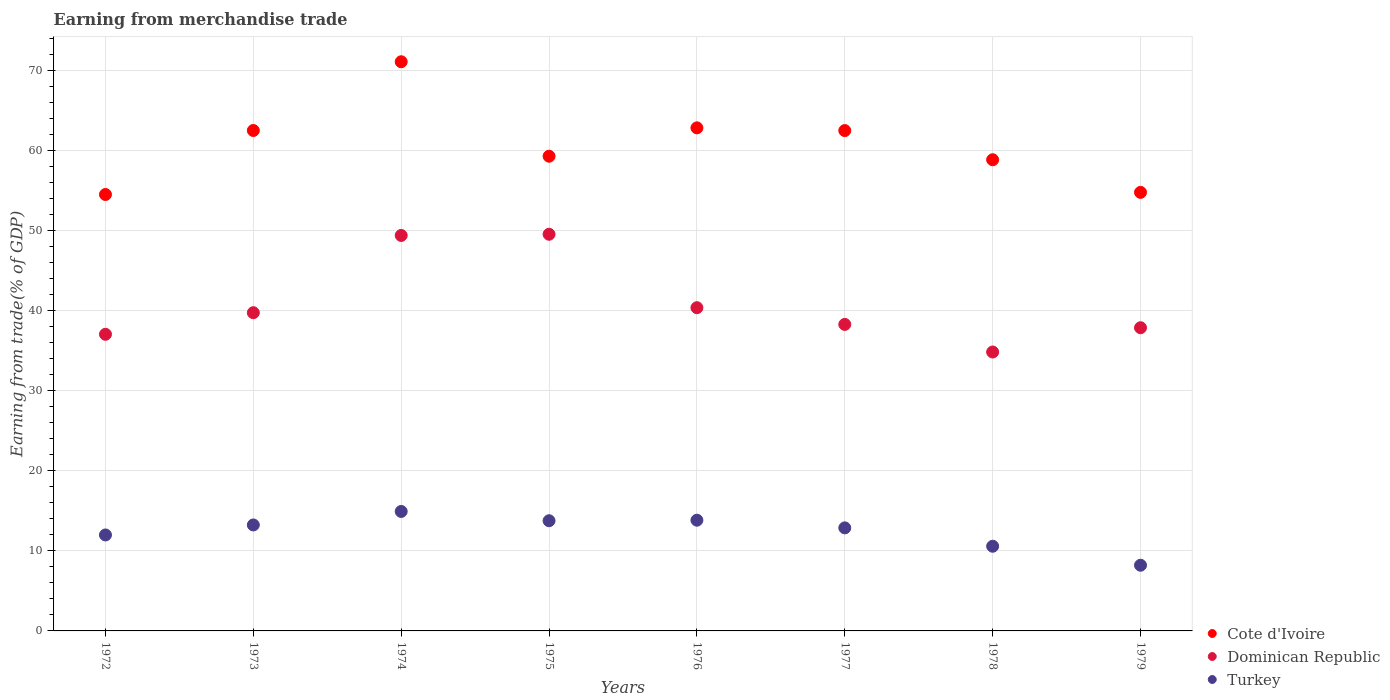Is the number of dotlines equal to the number of legend labels?
Provide a succinct answer. Yes. What is the earnings from trade in Turkey in 1974?
Give a very brief answer. 14.92. Across all years, what is the maximum earnings from trade in Turkey?
Keep it short and to the point. 14.92. Across all years, what is the minimum earnings from trade in Cote d'Ivoire?
Your answer should be very brief. 54.48. In which year was the earnings from trade in Dominican Republic maximum?
Your response must be concise. 1975. In which year was the earnings from trade in Cote d'Ivoire minimum?
Ensure brevity in your answer.  1972. What is the total earnings from trade in Cote d'Ivoire in the graph?
Your response must be concise. 486.13. What is the difference between the earnings from trade in Cote d'Ivoire in 1974 and that in 1978?
Provide a succinct answer. 12.23. What is the difference between the earnings from trade in Turkey in 1972 and the earnings from trade in Cote d'Ivoire in 1976?
Offer a very short reply. -50.83. What is the average earnings from trade in Cote d'Ivoire per year?
Offer a terse response. 60.77. In the year 1977, what is the difference between the earnings from trade in Cote d'Ivoire and earnings from trade in Dominican Republic?
Give a very brief answer. 24.2. What is the ratio of the earnings from trade in Dominican Republic in 1975 to that in 1977?
Offer a very short reply. 1.29. Is the difference between the earnings from trade in Cote d'Ivoire in 1977 and 1979 greater than the difference between the earnings from trade in Dominican Republic in 1977 and 1979?
Offer a terse response. Yes. What is the difference between the highest and the second highest earnings from trade in Turkey?
Offer a terse response. 1.09. What is the difference between the highest and the lowest earnings from trade in Cote d'Ivoire?
Your response must be concise. 16.57. Is the sum of the earnings from trade in Turkey in 1972 and 1975 greater than the maximum earnings from trade in Cote d'Ivoire across all years?
Provide a short and direct response. No. Is the earnings from trade in Dominican Republic strictly greater than the earnings from trade in Cote d'Ivoire over the years?
Ensure brevity in your answer.  No. Is the earnings from trade in Cote d'Ivoire strictly less than the earnings from trade in Turkey over the years?
Give a very brief answer. No. How many dotlines are there?
Your answer should be compact. 3. How many years are there in the graph?
Offer a very short reply. 8. Does the graph contain any zero values?
Your answer should be compact. No. Does the graph contain grids?
Your answer should be compact. Yes. How many legend labels are there?
Your answer should be very brief. 3. How are the legend labels stacked?
Keep it short and to the point. Vertical. What is the title of the graph?
Offer a terse response. Earning from merchandise trade. What is the label or title of the Y-axis?
Offer a very short reply. Earning from trade(% of GDP). What is the Earning from trade(% of GDP) of Cote d'Ivoire in 1972?
Make the answer very short. 54.48. What is the Earning from trade(% of GDP) of Dominican Republic in 1972?
Offer a terse response. 37.03. What is the Earning from trade(% of GDP) in Turkey in 1972?
Offer a terse response. 11.98. What is the Earning from trade(% of GDP) in Cote d'Ivoire in 1973?
Make the answer very short. 62.47. What is the Earning from trade(% of GDP) of Dominican Republic in 1973?
Ensure brevity in your answer.  39.73. What is the Earning from trade(% of GDP) of Turkey in 1973?
Provide a short and direct response. 13.23. What is the Earning from trade(% of GDP) of Cote d'Ivoire in 1974?
Keep it short and to the point. 71.06. What is the Earning from trade(% of GDP) in Dominican Republic in 1974?
Your answer should be compact. 49.37. What is the Earning from trade(% of GDP) in Turkey in 1974?
Give a very brief answer. 14.92. What is the Earning from trade(% of GDP) of Cote d'Ivoire in 1975?
Keep it short and to the point. 59.26. What is the Earning from trade(% of GDP) of Dominican Republic in 1975?
Ensure brevity in your answer.  49.52. What is the Earning from trade(% of GDP) of Turkey in 1975?
Provide a short and direct response. 13.76. What is the Earning from trade(% of GDP) of Cote d'Ivoire in 1976?
Make the answer very short. 62.81. What is the Earning from trade(% of GDP) in Dominican Republic in 1976?
Make the answer very short. 40.35. What is the Earning from trade(% of GDP) of Turkey in 1976?
Your answer should be very brief. 13.82. What is the Earning from trade(% of GDP) in Cote d'Ivoire in 1977?
Offer a terse response. 62.47. What is the Earning from trade(% of GDP) of Dominican Republic in 1977?
Your answer should be compact. 38.27. What is the Earning from trade(% of GDP) of Turkey in 1977?
Make the answer very short. 12.87. What is the Earning from trade(% of GDP) of Cote d'Ivoire in 1978?
Your answer should be compact. 58.82. What is the Earning from trade(% of GDP) in Dominican Republic in 1978?
Offer a terse response. 34.82. What is the Earning from trade(% of GDP) of Turkey in 1978?
Keep it short and to the point. 10.57. What is the Earning from trade(% of GDP) in Cote d'Ivoire in 1979?
Your answer should be compact. 54.75. What is the Earning from trade(% of GDP) in Dominican Republic in 1979?
Ensure brevity in your answer.  37.85. What is the Earning from trade(% of GDP) in Turkey in 1979?
Ensure brevity in your answer.  8.2. Across all years, what is the maximum Earning from trade(% of GDP) of Cote d'Ivoire?
Offer a very short reply. 71.06. Across all years, what is the maximum Earning from trade(% of GDP) of Dominican Republic?
Provide a succinct answer. 49.52. Across all years, what is the maximum Earning from trade(% of GDP) of Turkey?
Keep it short and to the point. 14.92. Across all years, what is the minimum Earning from trade(% of GDP) of Cote d'Ivoire?
Your response must be concise. 54.48. Across all years, what is the minimum Earning from trade(% of GDP) in Dominican Republic?
Give a very brief answer. 34.82. Across all years, what is the minimum Earning from trade(% of GDP) in Turkey?
Your response must be concise. 8.2. What is the total Earning from trade(% of GDP) of Cote d'Ivoire in the graph?
Ensure brevity in your answer.  486.13. What is the total Earning from trade(% of GDP) in Dominican Republic in the graph?
Make the answer very short. 326.95. What is the total Earning from trade(% of GDP) of Turkey in the graph?
Your answer should be compact. 99.34. What is the difference between the Earning from trade(% of GDP) of Cote d'Ivoire in 1972 and that in 1973?
Your answer should be compact. -7.99. What is the difference between the Earning from trade(% of GDP) of Dominican Republic in 1972 and that in 1973?
Give a very brief answer. -2.7. What is the difference between the Earning from trade(% of GDP) in Turkey in 1972 and that in 1973?
Provide a short and direct response. -1.25. What is the difference between the Earning from trade(% of GDP) in Cote d'Ivoire in 1972 and that in 1974?
Your answer should be compact. -16.57. What is the difference between the Earning from trade(% of GDP) in Dominican Republic in 1972 and that in 1974?
Ensure brevity in your answer.  -12.34. What is the difference between the Earning from trade(% of GDP) in Turkey in 1972 and that in 1974?
Provide a short and direct response. -2.94. What is the difference between the Earning from trade(% of GDP) of Cote d'Ivoire in 1972 and that in 1975?
Provide a succinct answer. -4.78. What is the difference between the Earning from trade(% of GDP) in Dominican Republic in 1972 and that in 1975?
Ensure brevity in your answer.  -12.49. What is the difference between the Earning from trade(% of GDP) of Turkey in 1972 and that in 1975?
Give a very brief answer. -1.78. What is the difference between the Earning from trade(% of GDP) in Cote d'Ivoire in 1972 and that in 1976?
Make the answer very short. -8.32. What is the difference between the Earning from trade(% of GDP) of Dominican Republic in 1972 and that in 1976?
Ensure brevity in your answer.  -3.32. What is the difference between the Earning from trade(% of GDP) in Turkey in 1972 and that in 1976?
Your answer should be very brief. -1.84. What is the difference between the Earning from trade(% of GDP) of Cote d'Ivoire in 1972 and that in 1977?
Provide a succinct answer. -7.98. What is the difference between the Earning from trade(% of GDP) of Dominican Republic in 1972 and that in 1977?
Your answer should be compact. -1.23. What is the difference between the Earning from trade(% of GDP) of Turkey in 1972 and that in 1977?
Provide a short and direct response. -0.89. What is the difference between the Earning from trade(% of GDP) in Cote d'Ivoire in 1972 and that in 1978?
Your answer should be very brief. -4.34. What is the difference between the Earning from trade(% of GDP) in Dominican Republic in 1972 and that in 1978?
Ensure brevity in your answer.  2.21. What is the difference between the Earning from trade(% of GDP) of Turkey in 1972 and that in 1978?
Give a very brief answer. 1.41. What is the difference between the Earning from trade(% of GDP) of Cote d'Ivoire in 1972 and that in 1979?
Give a very brief answer. -0.27. What is the difference between the Earning from trade(% of GDP) in Dominican Republic in 1972 and that in 1979?
Provide a short and direct response. -0.82. What is the difference between the Earning from trade(% of GDP) of Turkey in 1972 and that in 1979?
Provide a succinct answer. 3.78. What is the difference between the Earning from trade(% of GDP) of Cote d'Ivoire in 1973 and that in 1974?
Provide a short and direct response. -8.58. What is the difference between the Earning from trade(% of GDP) of Dominican Republic in 1973 and that in 1974?
Give a very brief answer. -9.64. What is the difference between the Earning from trade(% of GDP) of Turkey in 1973 and that in 1974?
Your response must be concise. -1.69. What is the difference between the Earning from trade(% of GDP) in Cote d'Ivoire in 1973 and that in 1975?
Offer a terse response. 3.21. What is the difference between the Earning from trade(% of GDP) of Dominican Republic in 1973 and that in 1975?
Your answer should be compact. -9.79. What is the difference between the Earning from trade(% of GDP) of Turkey in 1973 and that in 1975?
Offer a terse response. -0.53. What is the difference between the Earning from trade(% of GDP) in Cote d'Ivoire in 1973 and that in 1976?
Provide a succinct answer. -0.33. What is the difference between the Earning from trade(% of GDP) in Dominican Republic in 1973 and that in 1976?
Provide a succinct answer. -0.62. What is the difference between the Earning from trade(% of GDP) in Turkey in 1973 and that in 1976?
Give a very brief answer. -0.59. What is the difference between the Earning from trade(% of GDP) of Cote d'Ivoire in 1973 and that in 1977?
Your response must be concise. 0.01. What is the difference between the Earning from trade(% of GDP) in Dominican Republic in 1973 and that in 1977?
Give a very brief answer. 1.46. What is the difference between the Earning from trade(% of GDP) in Turkey in 1973 and that in 1977?
Offer a very short reply. 0.36. What is the difference between the Earning from trade(% of GDP) in Cote d'Ivoire in 1973 and that in 1978?
Your response must be concise. 3.65. What is the difference between the Earning from trade(% of GDP) of Dominican Republic in 1973 and that in 1978?
Provide a short and direct response. 4.91. What is the difference between the Earning from trade(% of GDP) of Turkey in 1973 and that in 1978?
Your answer should be compact. 2.66. What is the difference between the Earning from trade(% of GDP) of Cote d'Ivoire in 1973 and that in 1979?
Your response must be concise. 7.72. What is the difference between the Earning from trade(% of GDP) of Dominican Republic in 1973 and that in 1979?
Offer a terse response. 1.88. What is the difference between the Earning from trade(% of GDP) of Turkey in 1973 and that in 1979?
Your response must be concise. 5.03. What is the difference between the Earning from trade(% of GDP) of Cote d'Ivoire in 1974 and that in 1975?
Provide a succinct answer. 11.79. What is the difference between the Earning from trade(% of GDP) of Dominican Republic in 1974 and that in 1975?
Offer a terse response. -0.15. What is the difference between the Earning from trade(% of GDP) in Turkey in 1974 and that in 1975?
Ensure brevity in your answer.  1.16. What is the difference between the Earning from trade(% of GDP) in Cote d'Ivoire in 1974 and that in 1976?
Offer a terse response. 8.25. What is the difference between the Earning from trade(% of GDP) of Dominican Republic in 1974 and that in 1976?
Your answer should be very brief. 9.02. What is the difference between the Earning from trade(% of GDP) of Turkey in 1974 and that in 1976?
Offer a terse response. 1.09. What is the difference between the Earning from trade(% of GDP) of Cote d'Ivoire in 1974 and that in 1977?
Offer a terse response. 8.59. What is the difference between the Earning from trade(% of GDP) in Dominican Republic in 1974 and that in 1977?
Ensure brevity in your answer.  11.11. What is the difference between the Earning from trade(% of GDP) of Turkey in 1974 and that in 1977?
Make the answer very short. 2.05. What is the difference between the Earning from trade(% of GDP) in Cote d'Ivoire in 1974 and that in 1978?
Offer a terse response. 12.23. What is the difference between the Earning from trade(% of GDP) of Dominican Republic in 1974 and that in 1978?
Provide a short and direct response. 14.55. What is the difference between the Earning from trade(% of GDP) in Turkey in 1974 and that in 1978?
Offer a terse response. 4.34. What is the difference between the Earning from trade(% of GDP) in Cote d'Ivoire in 1974 and that in 1979?
Give a very brief answer. 16.31. What is the difference between the Earning from trade(% of GDP) in Dominican Republic in 1974 and that in 1979?
Make the answer very short. 11.52. What is the difference between the Earning from trade(% of GDP) of Turkey in 1974 and that in 1979?
Ensure brevity in your answer.  6.71. What is the difference between the Earning from trade(% of GDP) of Cote d'Ivoire in 1975 and that in 1976?
Keep it short and to the point. -3.54. What is the difference between the Earning from trade(% of GDP) of Dominican Republic in 1975 and that in 1976?
Your response must be concise. 9.17. What is the difference between the Earning from trade(% of GDP) of Turkey in 1975 and that in 1976?
Provide a succinct answer. -0.07. What is the difference between the Earning from trade(% of GDP) in Cote d'Ivoire in 1975 and that in 1977?
Your response must be concise. -3.2. What is the difference between the Earning from trade(% of GDP) of Dominican Republic in 1975 and that in 1977?
Your response must be concise. 11.25. What is the difference between the Earning from trade(% of GDP) of Turkey in 1975 and that in 1977?
Your response must be concise. 0.89. What is the difference between the Earning from trade(% of GDP) in Cote d'Ivoire in 1975 and that in 1978?
Provide a short and direct response. 0.44. What is the difference between the Earning from trade(% of GDP) of Dominican Republic in 1975 and that in 1978?
Your answer should be compact. 14.7. What is the difference between the Earning from trade(% of GDP) in Turkey in 1975 and that in 1978?
Ensure brevity in your answer.  3.18. What is the difference between the Earning from trade(% of GDP) in Cote d'Ivoire in 1975 and that in 1979?
Your answer should be very brief. 4.51. What is the difference between the Earning from trade(% of GDP) of Dominican Republic in 1975 and that in 1979?
Make the answer very short. 11.67. What is the difference between the Earning from trade(% of GDP) in Turkey in 1975 and that in 1979?
Keep it short and to the point. 5.56. What is the difference between the Earning from trade(% of GDP) of Cote d'Ivoire in 1976 and that in 1977?
Offer a terse response. 0.34. What is the difference between the Earning from trade(% of GDP) in Dominican Republic in 1976 and that in 1977?
Offer a very short reply. 2.09. What is the difference between the Earning from trade(% of GDP) of Turkey in 1976 and that in 1977?
Ensure brevity in your answer.  0.96. What is the difference between the Earning from trade(% of GDP) of Cote d'Ivoire in 1976 and that in 1978?
Your response must be concise. 3.98. What is the difference between the Earning from trade(% of GDP) in Dominican Republic in 1976 and that in 1978?
Your response must be concise. 5.53. What is the difference between the Earning from trade(% of GDP) in Turkey in 1976 and that in 1978?
Your response must be concise. 3.25. What is the difference between the Earning from trade(% of GDP) of Cote d'Ivoire in 1976 and that in 1979?
Keep it short and to the point. 8.05. What is the difference between the Earning from trade(% of GDP) of Dominican Republic in 1976 and that in 1979?
Provide a succinct answer. 2.5. What is the difference between the Earning from trade(% of GDP) of Turkey in 1976 and that in 1979?
Make the answer very short. 5.62. What is the difference between the Earning from trade(% of GDP) of Cote d'Ivoire in 1977 and that in 1978?
Keep it short and to the point. 3.64. What is the difference between the Earning from trade(% of GDP) of Dominican Republic in 1977 and that in 1978?
Provide a succinct answer. 3.45. What is the difference between the Earning from trade(% of GDP) in Turkey in 1977 and that in 1978?
Your answer should be compact. 2.29. What is the difference between the Earning from trade(% of GDP) in Cote d'Ivoire in 1977 and that in 1979?
Keep it short and to the point. 7.71. What is the difference between the Earning from trade(% of GDP) in Dominican Republic in 1977 and that in 1979?
Ensure brevity in your answer.  0.42. What is the difference between the Earning from trade(% of GDP) in Turkey in 1977 and that in 1979?
Make the answer very short. 4.67. What is the difference between the Earning from trade(% of GDP) in Cote d'Ivoire in 1978 and that in 1979?
Give a very brief answer. 4.07. What is the difference between the Earning from trade(% of GDP) of Dominican Republic in 1978 and that in 1979?
Provide a succinct answer. -3.03. What is the difference between the Earning from trade(% of GDP) of Turkey in 1978 and that in 1979?
Provide a succinct answer. 2.37. What is the difference between the Earning from trade(% of GDP) of Cote d'Ivoire in 1972 and the Earning from trade(% of GDP) of Dominican Republic in 1973?
Make the answer very short. 14.76. What is the difference between the Earning from trade(% of GDP) of Cote d'Ivoire in 1972 and the Earning from trade(% of GDP) of Turkey in 1973?
Offer a very short reply. 41.25. What is the difference between the Earning from trade(% of GDP) in Dominican Republic in 1972 and the Earning from trade(% of GDP) in Turkey in 1973?
Provide a short and direct response. 23.8. What is the difference between the Earning from trade(% of GDP) in Cote d'Ivoire in 1972 and the Earning from trade(% of GDP) in Dominican Republic in 1974?
Provide a succinct answer. 5.11. What is the difference between the Earning from trade(% of GDP) in Cote d'Ivoire in 1972 and the Earning from trade(% of GDP) in Turkey in 1974?
Offer a very short reply. 39.57. What is the difference between the Earning from trade(% of GDP) in Dominican Republic in 1972 and the Earning from trade(% of GDP) in Turkey in 1974?
Your answer should be compact. 22.12. What is the difference between the Earning from trade(% of GDP) of Cote d'Ivoire in 1972 and the Earning from trade(% of GDP) of Dominican Republic in 1975?
Offer a very short reply. 4.96. What is the difference between the Earning from trade(% of GDP) of Cote d'Ivoire in 1972 and the Earning from trade(% of GDP) of Turkey in 1975?
Your answer should be very brief. 40.73. What is the difference between the Earning from trade(% of GDP) of Dominican Republic in 1972 and the Earning from trade(% of GDP) of Turkey in 1975?
Offer a very short reply. 23.28. What is the difference between the Earning from trade(% of GDP) of Cote d'Ivoire in 1972 and the Earning from trade(% of GDP) of Dominican Republic in 1976?
Offer a terse response. 14.13. What is the difference between the Earning from trade(% of GDP) in Cote d'Ivoire in 1972 and the Earning from trade(% of GDP) in Turkey in 1976?
Your answer should be very brief. 40.66. What is the difference between the Earning from trade(% of GDP) in Dominican Republic in 1972 and the Earning from trade(% of GDP) in Turkey in 1976?
Your answer should be very brief. 23.21. What is the difference between the Earning from trade(% of GDP) of Cote d'Ivoire in 1972 and the Earning from trade(% of GDP) of Dominican Republic in 1977?
Your answer should be compact. 16.22. What is the difference between the Earning from trade(% of GDP) in Cote d'Ivoire in 1972 and the Earning from trade(% of GDP) in Turkey in 1977?
Keep it short and to the point. 41.62. What is the difference between the Earning from trade(% of GDP) of Dominican Republic in 1972 and the Earning from trade(% of GDP) of Turkey in 1977?
Ensure brevity in your answer.  24.17. What is the difference between the Earning from trade(% of GDP) of Cote d'Ivoire in 1972 and the Earning from trade(% of GDP) of Dominican Republic in 1978?
Your answer should be very brief. 19.66. What is the difference between the Earning from trade(% of GDP) of Cote d'Ivoire in 1972 and the Earning from trade(% of GDP) of Turkey in 1978?
Offer a very short reply. 43.91. What is the difference between the Earning from trade(% of GDP) in Dominican Republic in 1972 and the Earning from trade(% of GDP) in Turkey in 1978?
Give a very brief answer. 26.46. What is the difference between the Earning from trade(% of GDP) of Cote d'Ivoire in 1972 and the Earning from trade(% of GDP) of Dominican Republic in 1979?
Make the answer very short. 16.63. What is the difference between the Earning from trade(% of GDP) of Cote d'Ivoire in 1972 and the Earning from trade(% of GDP) of Turkey in 1979?
Your answer should be very brief. 46.28. What is the difference between the Earning from trade(% of GDP) in Dominican Republic in 1972 and the Earning from trade(% of GDP) in Turkey in 1979?
Make the answer very short. 28.83. What is the difference between the Earning from trade(% of GDP) of Cote d'Ivoire in 1973 and the Earning from trade(% of GDP) of Dominican Republic in 1974?
Your answer should be very brief. 13.1. What is the difference between the Earning from trade(% of GDP) of Cote d'Ivoire in 1973 and the Earning from trade(% of GDP) of Turkey in 1974?
Keep it short and to the point. 47.56. What is the difference between the Earning from trade(% of GDP) of Dominican Republic in 1973 and the Earning from trade(% of GDP) of Turkey in 1974?
Offer a terse response. 24.81. What is the difference between the Earning from trade(% of GDP) in Cote d'Ivoire in 1973 and the Earning from trade(% of GDP) in Dominican Republic in 1975?
Keep it short and to the point. 12.95. What is the difference between the Earning from trade(% of GDP) of Cote d'Ivoire in 1973 and the Earning from trade(% of GDP) of Turkey in 1975?
Your answer should be very brief. 48.72. What is the difference between the Earning from trade(% of GDP) of Dominican Republic in 1973 and the Earning from trade(% of GDP) of Turkey in 1975?
Your answer should be very brief. 25.97. What is the difference between the Earning from trade(% of GDP) in Cote d'Ivoire in 1973 and the Earning from trade(% of GDP) in Dominican Republic in 1976?
Offer a very short reply. 22.12. What is the difference between the Earning from trade(% of GDP) in Cote d'Ivoire in 1973 and the Earning from trade(% of GDP) in Turkey in 1976?
Offer a terse response. 48.65. What is the difference between the Earning from trade(% of GDP) in Dominican Republic in 1973 and the Earning from trade(% of GDP) in Turkey in 1976?
Keep it short and to the point. 25.9. What is the difference between the Earning from trade(% of GDP) of Cote d'Ivoire in 1973 and the Earning from trade(% of GDP) of Dominican Republic in 1977?
Provide a short and direct response. 24.21. What is the difference between the Earning from trade(% of GDP) in Cote d'Ivoire in 1973 and the Earning from trade(% of GDP) in Turkey in 1977?
Keep it short and to the point. 49.61. What is the difference between the Earning from trade(% of GDP) in Dominican Republic in 1973 and the Earning from trade(% of GDP) in Turkey in 1977?
Make the answer very short. 26.86. What is the difference between the Earning from trade(% of GDP) in Cote d'Ivoire in 1973 and the Earning from trade(% of GDP) in Dominican Republic in 1978?
Your answer should be very brief. 27.65. What is the difference between the Earning from trade(% of GDP) of Cote d'Ivoire in 1973 and the Earning from trade(% of GDP) of Turkey in 1978?
Your response must be concise. 51.9. What is the difference between the Earning from trade(% of GDP) of Dominican Republic in 1973 and the Earning from trade(% of GDP) of Turkey in 1978?
Offer a very short reply. 29.16. What is the difference between the Earning from trade(% of GDP) of Cote d'Ivoire in 1973 and the Earning from trade(% of GDP) of Dominican Republic in 1979?
Offer a terse response. 24.62. What is the difference between the Earning from trade(% of GDP) in Cote d'Ivoire in 1973 and the Earning from trade(% of GDP) in Turkey in 1979?
Offer a terse response. 54.27. What is the difference between the Earning from trade(% of GDP) in Dominican Republic in 1973 and the Earning from trade(% of GDP) in Turkey in 1979?
Give a very brief answer. 31.53. What is the difference between the Earning from trade(% of GDP) of Cote d'Ivoire in 1974 and the Earning from trade(% of GDP) of Dominican Republic in 1975?
Your response must be concise. 21.54. What is the difference between the Earning from trade(% of GDP) of Cote d'Ivoire in 1974 and the Earning from trade(% of GDP) of Turkey in 1975?
Keep it short and to the point. 57.3. What is the difference between the Earning from trade(% of GDP) of Dominican Republic in 1974 and the Earning from trade(% of GDP) of Turkey in 1975?
Give a very brief answer. 35.62. What is the difference between the Earning from trade(% of GDP) in Cote d'Ivoire in 1974 and the Earning from trade(% of GDP) in Dominican Republic in 1976?
Provide a short and direct response. 30.7. What is the difference between the Earning from trade(% of GDP) of Cote d'Ivoire in 1974 and the Earning from trade(% of GDP) of Turkey in 1976?
Keep it short and to the point. 57.23. What is the difference between the Earning from trade(% of GDP) of Dominican Republic in 1974 and the Earning from trade(% of GDP) of Turkey in 1976?
Ensure brevity in your answer.  35.55. What is the difference between the Earning from trade(% of GDP) of Cote d'Ivoire in 1974 and the Earning from trade(% of GDP) of Dominican Republic in 1977?
Your response must be concise. 32.79. What is the difference between the Earning from trade(% of GDP) of Cote d'Ivoire in 1974 and the Earning from trade(% of GDP) of Turkey in 1977?
Offer a very short reply. 58.19. What is the difference between the Earning from trade(% of GDP) in Dominican Republic in 1974 and the Earning from trade(% of GDP) in Turkey in 1977?
Your answer should be very brief. 36.51. What is the difference between the Earning from trade(% of GDP) in Cote d'Ivoire in 1974 and the Earning from trade(% of GDP) in Dominican Republic in 1978?
Provide a succinct answer. 36.24. What is the difference between the Earning from trade(% of GDP) in Cote d'Ivoire in 1974 and the Earning from trade(% of GDP) in Turkey in 1978?
Offer a terse response. 60.49. What is the difference between the Earning from trade(% of GDP) in Dominican Republic in 1974 and the Earning from trade(% of GDP) in Turkey in 1978?
Make the answer very short. 38.8. What is the difference between the Earning from trade(% of GDP) of Cote d'Ivoire in 1974 and the Earning from trade(% of GDP) of Dominican Republic in 1979?
Give a very brief answer. 33.21. What is the difference between the Earning from trade(% of GDP) in Cote d'Ivoire in 1974 and the Earning from trade(% of GDP) in Turkey in 1979?
Keep it short and to the point. 62.86. What is the difference between the Earning from trade(% of GDP) of Dominican Republic in 1974 and the Earning from trade(% of GDP) of Turkey in 1979?
Provide a succinct answer. 41.17. What is the difference between the Earning from trade(% of GDP) of Cote d'Ivoire in 1975 and the Earning from trade(% of GDP) of Dominican Republic in 1976?
Provide a short and direct response. 18.91. What is the difference between the Earning from trade(% of GDP) in Cote d'Ivoire in 1975 and the Earning from trade(% of GDP) in Turkey in 1976?
Offer a very short reply. 45.44. What is the difference between the Earning from trade(% of GDP) in Dominican Republic in 1975 and the Earning from trade(% of GDP) in Turkey in 1976?
Keep it short and to the point. 35.7. What is the difference between the Earning from trade(% of GDP) in Cote d'Ivoire in 1975 and the Earning from trade(% of GDP) in Dominican Republic in 1977?
Offer a very short reply. 21. What is the difference between the Earning from trade(% of GDP) in Cote d'Ivoire in 1975 and the Earning from trade(% of GDP) in Turkey in 1977?
Keep it short and to the point. 46.4. What is the difference between the Earning from trade(% of GDP) in Dominican Republic in 1975 and the Earning from trade(% of GDP) in Turkey in 1977?
Offer a very short reply. 36.66. What is the difference between the Earning from trade(% of GDP) of Cote d'Ivoire in 1975 and the Earning from trade(% of GDP) of Dominican Republic in 1978?
Keep it short and to the point. 24.44. What is the difference between the Earning from trade(% of GDP) of Cote d'Ivoire in 1975 and the Earning from trade(% of GDP) of Turkey in 1978?
Offer a very short reply. 48.69. What is the difference between the Earning from trade(% of GDP) in Dominican Republic in 1975 and the Earning from trade(% of GDP) in Turkey in 1978?
Make the answer very short. 38.95. What is the difference between the Earning from trade(% of GDP) in Cote d'Ivoire in 1975 and the Earning from trade(% of GDP) in Dominican Republic in 1979?
Provide a succinct answer. 21.41. What is the difference between the Earning from trade(% of GDP) of Cote d'Ivoire in 1975 and the Earning from trade(% of GDP) of Turkey in 1979?
Your answer should be compact. 51.06. What is the difference between the Earning from trade(% of GDP) in Dominican Republic in 1975 and the Earning from trade(% of GDP) in Turkey in 1979?
Make the answer very short. 41.32. What is the difference between the Earning from trade(% of GDP) in Cote d'Ivoire in 1976 and the Earning from trade(% of GDP) in Dominican Republic in 1977?
Your response must be concise. 24.54. What is the difference between the Earning from trade(% of GDP) in Cote d'Ivoire in 1976 and the Earning from trade(% of GDP) in Turkey in 1977?
Your answer should be compact. 49.94. What is the difference between the Earning from trade(% of GDP) in Dominican Republic in 1976 and the Earning from trade(% of GDP) in Turkey in 1977?
Offer a terse response. 27.49. What is the difference between the Earning from trade(% of GDP) in Cote d'Ivoire in 1976 and the Earning from trade(% of GDP) in Dominican Republic in 1978?
Provide a succinct answer. 27.98. What is the difference between the Earning from trade(% of GDP) of Cote d'Ivoire in 1976 and the Earning from trade(% of GDP) of Turkey in 1978?
Offer a terse response. 52.23. What is the difference between the Earning from trade(% of GDP) of Dominican Republic in 1976 and the Earning from trade(% of GDP) of Turkey in 1978?
Ensure brevity in your answer.  29.78. What is the difference between the Earning from trade(% of GDP) of Cote d'Ivoire in 1976 and the Earning from trade(% of GDP) of Dominican Republic in 1979?
Give a very brief answer. 24.95. What is the difference between the Earning from trade(% of GDP) in Cote d'Ivoire in 1976 and the Earning from trade(% of GDP) in Turkey in 1979?
Make the answer very short. 54.6. What is the difference between the Earning from trade(% of GDP) of Dominican Republic in 1976 and the Earning from trade(% of GDP) of Turkey in 1979?
Keep it short and to the point. 32.15. What is the difference between the Earning from trade(% of GDP) in Cote d'Ivoire in 1977 and the Earning from trade(% of GDP) in Dominican Republic in 1978?
Give a very brief answer. 27.64. What is the difference between the Earning from trade(% of GDP) in Cote d'Ivoire in 1977 and the Earning from trade(% of GDP) in Turkey in 1978?
Provide a succinct answer. 51.89. What is the difference between the Earning from trade(% of GDP) of Dominican Republic in 1977 and the Earning from trade(% of GDP) of Turkey in 1978?
Provide a short and direct response. 27.7. What is the difference between the Earning from trade(% of GDP) in Cote d'Ivoire in 1977 and the Earning from trade(% of GDP) in Dominican Republic in 1979?
Provide a succinct answer. 24.61. What is the difference between the Earning from trade(% of GDP) in Cote d'Ivoire in 1977 and the Earning from trade(% of GDP) in Turkey in 1979?
Provide a short and direct response. 54.26. What is the difference between the Earning from trade(% of GDP) in Dominican Republic in 1977 and the Earning from trade(% of GDP) in Turkey in 1979?
Keep it short and to the point. 30.07. What is the difference between the Earning from trade(% of GDP) of Cote d'Ivoire in 1978 and the Earning from trade(% of GDP) of Dominican Republic in 1979?
Your answer should be very brief. 20.97. What is the difference between the Earning from trade(% of GDP) of Cote d'Ivoire in 1978 and the Earning from trade(% of GDP) of Turkey in 1979?
Give a very brief answer. 50.62. What is the difference between the Earning from trade(% of GDP) of Dominican Republic in 1978 and the Earning from trade(% of GDP) of Turkey in 1979?
Offer a terse response. 26.62. What is the average Earning from trade(% of GDP) of Cote d'Ivoire per year?
Provide a succinct answer. 60.77. What is the average Earning from trade(% of GDP) in Dominican Republic per year?
Give a very brief answer. 40.87. What is the average Earning from trade(% of GDP) in Turkey per year?
Keep it short and to the point. 12.42. In the year 1972, what is the difference between the Earning from trade(% of GDP) of Cote d'Ivoire and Earning from trade(% of GDP) of Dominican Republic?
Provide a short and direct response. 17.45. In the year 1972, what is the difference between the Earning from trade(% of GDP) of Cote d'Ivoire and Earning from trade(% of GDP) of Turkey?
Make the answer very short. 42.5. In the year 1972, what is the difference between the Earning from trade(% of GDP) of Dominican Republic and Earning from trade(% of GDP) of Turkey?
Provide a short and direct response. 25.05. In the year 1973, what is the difference between the Earning from trade(% of GDP) of Cote d'Ivoire and Earning from trade(% of GDP) of Dominican Republic?
Offer a terse response. 22.75. In the year 1973, what is the difference between the Earning from trade(% of GDP) of Cote d'Ivoire and Earning from trade(% of GDP) of Turkey?
Your answer should be very brief. 49.25. In the year 1973, what is the difference between the Earning from trade(% of GDP) of Dominican Republic and Earning from trade(% of GDP) of Turkey?
Provide a short and direct response. 26.5. In the year 1974, what is the difference between the Earning from trade(% of GDP) of Cote d'Ivoire and Earning from trade(% of GDP) of Dominican Republic?
Keep it short and to the point. 21.69. In the year 1974, what is the difference between the Earning from trade(% of GDP) of Cote d'Ivoire and Earning from trade(% of GDP) of Turkey?
Your response must be concise. 56.14. In the year 1974, what is the difference between the Earning from trade(% of GDP) of Dominican Republic and Earning from trade(% of GDP) of Turkey?
Ensure brevity in your answer.  34.46. In the year 1975, what is the difference between the Earning from trade(% of GDP) in Cote d'Ivoire and Earning from trade(% of GDP) in Dominican Republic?
Your response must be concise. 9.74. In the year 1975, what is the difference between the Earning from trade(% of GDP) in Cote d'Ivoire and Earning from trade(% of GDP) in Turkey?
Keep it short and to the point. 45.51. In the year 1975, what is the difference between the Earning from trade(% of GDP) in Dominican Republic and Earning from trade(% of GDP) in Turkey?
Keep it short and to the point. 35.77. In the year 1976, what is the difference between the Earning from trade(% of GDP) in Cote d'Ivoire and Earning from trade(% of GDP) in Dominican Republic?
Offer a very short reply. 22.45. In the year 1976, what is the difference between the Earning from trade(% of GDP) in Cote d'Ivoire and Earning from trade(% of GDP) in Turkey?
Offer a terse response. 48.98. In the year 1976, what is the difference between the Earning from trade(% of GDP) of Dominican Republic and Earning from trade(% of GDP) of Turkey?
Your response must be concise. 26.53. In the year 1977, what is the difference between the Earning from trade(% of GDP) of Cote d'Ivoire and Earning from trade(% of GDP) of Dominican Republic?
Provide a short and direct response. 24.2. In the year 1977, what is the difference between the Earning from trade(% of GDP) of Cote d'Ivoire and Earning from trade(% of GDP) of Turkey?
Your response must be concise. 49.6. In the year 1977, what is the difference between the Earning from trade(% of GDP) of Dominican Republic and Earning from trade(% of GDP) of Turkey?
Your response must be concise. 25.4. In the year 1978, what is the difference between the Earning from trade(% of GDP) in Cote d'Ivoire and Earning from trade(% of GDP) in Dominican Republic?
Keep it short and to the point. 24. In the year 1978, what is the difference between the Earning from trade(% of GDP) of Cote d'Ivoire and Earning from trade(% of GDP) of Turkey?
Your response must be concise. 48.25. In the year 1978, what is the difference between the Earning from trade(% of GDP) of Dominican Republic and Earning from trade(% of GDP) of Turkey?
Provide a short and direct response. 24.25. In the year 1979, what is the difference between the Earning from trade(% of GDP) of Cote d'Ivoire and Earning from trade(% of GDP) of Dominican Republic?
Provide a short and direct response. 16.9. In the year 1979, what is the difference between the Earning from trade(% of GDP) in Cote d'Ivoire and Earning from trade(% of GDP) in Turkey?
Your response must be concise. 46.55. In the year 1979, what is the difference between the Earning from trade(% of GDP) in Dominican Republic and Earning from trade(% of GDP) in Turkey?
Offer a very short reply. 29.65. What is the ratio of the Earning from trade(% of GDP) of Cote d'Ivoire in 1972 to that in 1973?
Provide a short and direct response. 0.87. What is the ratio of the Earning from trade(% of GDP) of Dominican Republic in 1972 to that in 1973?
Offer a very short reply. 0.93. What is the ratio of the Earning from trade(% of GDP) in Turkey in 1972 to that in 1973?
Your response must be concise. 0.91. What is the ratio of the Earning from trade(% of GDP) of Cote d'Ivoire in 1972 to that in 1974?
Offer a very short reply. 0.77. What is the ratio of the Earning from trade(% of GDP) of Dominican Republic in 1972 to that in 1974?
Provide a succinct answer. 0.75. What is the ratio of the Earning from trade(% of GDP) in Turkey in 1972 to that in 1974?
Ensure brevity in your answer.  0.8. What is the ratio of the Earning from trade(% of GDP) of Cote d'Ivoire in 1972 to that in 1975?
Your answer should be compact. 0.92. What is the ratio of the Earning from trade(% of GDP) of Dominican Republic in 1972 to that in 1975?
Your answer should be very brief. 0.75. What is the ratio of the Earning from trade(% of GDP) in Turkey in 1972 to that in 1975?
Your response must be concise. 0.87. What is the ratio of the Earning from trade(% of GDP) of Cote d'Ivoire in 1972 to that in 1976?
Offer a very short reply. 0.87. What is the ratio of the Earning from trade(% of GDP) of Dominican Republic in 1972 to that in 1976?
Provide a succinct answer. 0.92. What is the ratio of the Earning from trade(% of GDP) in Turkey in 1972 to that in 1976?
Your response must be concise. 0.87. What is the ratio of the Earning from trade(% of GDP) of Cote d'Ivoire in 1972 to that in 1977?
Provide a succinct answer. 0.87. What is the ratio of the Earning from trade(% of GDP) in Dominican Republic in 1972 to that in 1977?
Offer a very short reply. 0.97. What is the ratio of the Earning from trade(% of GDP) of Turkey in 1972 to that in 1977?
Offer a terse response. 0.93. What is the ratio of the Earning from trade(% of GDP) in Cote d'Ivoire in 1972 to that in 1978?
Give a very brief answer. 0.93. What is the ratio of the Earning from trade(% of GDP) of Dominican Republic in 1972 to that in 1978?
Offer a very short reply. 1.06. What is the ratio of the Earning from trade(% of GDP) of Turkey in 1972 to that in 1978?
Offer a terse response. 1.13. What is the ratio of the Earning from trade(% of GDP) of Cote d'Ivoire in 1972 to that in 1979?
Provide a short and direct response. 1. What is the ratio of the Earning from trade(% of GDP) of Dominican Republic in 1972 to that in 1979?
Keep it short and to the point. 0.98. What is the ratio of the Earning from trade(% of GDP) of Turkey in 1972 to that in 1979?
Your answer should be compact. 1.46. What is the ratio of the Earning from trade(% of GDP) of Cote d'Ivoire in 1973 to that in 1974?
Your response must be concise. 0.88. What is the ratio of the Earning from trade(% of GDP) of Dominican Republic in 1973 to that in 1974?
Offer a very short reply. 0.8. What is the ratio of the Earning from trade(% of GDP) in Turkey in 1973 to that in 1974?
Offer a terse response. 0.89. What is the ratio of the Earning from trade(% of GDP) in Cote d'Ivoire in 1973 to that in 1975?
Your response must be concise. 1.05. What is the ratio of the Earning from trade(% of GDP) of Dominican Republic in 1973 to that in 1975?
Give a very brief answer. 0.8. What is the ratio of the Earning from trade(% of GDP) of Turkey in 1973 to that in 1975?
Your answer should be very brief. 0.96. What is the ratio of the Earning from trade(% of GDP) of Cote d'Ivoire in 1973 to that in 1976?
Make the answer very short. 0.99. What is the ratio of the Earning from trade(% of GDP) of Dominican Republic in 1973 to that in 1976?
Your response must be concise. 0.98. What is the ratio of the Earning from trade(% of GDP) in Turkey in 1973 to that in 1976?
Keep it short and to the point. 0.96. What is the ratio of the Earning from trade(% of GDP) of Cote d'Ivoire in 1973 to that in 1977?
Your answer should be compact. 1. What is the ratio of the Earning from trade(% of GDP) in Dominican Republic in 1973 to that in 1977?
Keep it short and to the point. 1.04. What is the ratio of the Earning from trade(% of GDP) of Turkey in 1973 to that in 1977?
Offer a terse response. 1.03. What is the ratio of the Earning from trade(% of GDP) of Cote d'Ivoire in 1973 to that in 1978?
Offer a very short reply. 1.06. What is the ratio of the Earning from trade(% of GDP) of Dominican Republic in 1973 to that in 1978?
Ensure brevity in your answer.  1.14. What is the ratio of the Earning from trade(% of GDP) in Turkey in 1973 to that in 1978?
Your response must be concise. 1.25. What is the ratio of the Earning from trade(% of GDP) in Cote d'Ivoire in 1973 to that in 1979?
Give a very brief answer. 1.14. What is the ratio of the Earning from trade(% of GDP) in Dominican Republic in 1973 to that in 1979?
Provide a succinct answer. 1.05. What is the ratio of the Earning from trade(% of GDP) of Turkey in 1973 to that in 1979?
Ensure brevity in your answer.  1.61. What is the ratio of the Earning from trade(% of GDP) of Cote d'Ivoire in 1974 to that in 1975?
Give a very brief answer. 1.2. What is the ratio of the Earning from trade(% of GDP) in Turkey in 1974 to that in 1975?
Keep it short and to the point. 1.08. What is the ratio of the Earning from trade(% of GDP) in Cote d'Ivoire in 1974 to that in 1976?
Give a very brief answer. 1.13. What is the ratio of the Earning from trade(% of GDP) of Dominican Republic in 1974 to that in 1976?
Give a very brief answer. 1.22. What is the ratio of the Earning from trade(% of GDP) in Turkey in 1974 to that in 1976?
Your answer should be very brief. 1.08. What is the ratio of the Earning from trade(% of GDP) of Cote d'Ivoire in 1974 to that in 1977?
Your answer should be very brief. 1.14. What is the ratio of the Earning from trade(% of GDP) in Dominican Republic in 1974 to that in 1977?
Provide a succinct answer. 1.29. What is the ratio of the Earning from trade(% of GDP) in Turkey in 1974 to that in 1977?
Your answer should be very brief. 1.16. What is the ratio of the Earning from trade(% of GDP) of Cote d'Ivoire in 1974 to that in 1978?
Offer a terse response. 1.21. What is the ratio of the Earning from trade(% of GDP) of Dominican Republic in 1974 to that in 1978?
Keep it short and to the point. 1.42. What is the ratio of the Earning from trade(% of GDP) of Turkey in 1974 to that in 1978?
Offer a terse response. 1.41. What is the ratio of the Earning from trade(% of GDP) in Cote d'Ivoire in 1974 to that in 1979?
Give a very brief answer. 1.3. What is the ratio of the Earning from trade(% of GDP) in Dominican Republic in 1974 to that in 1979?
Provide a succinct answer. 1.3. What is the ratio of the Earning from trade(% of GDP) in Turkey in 1974 to that in 1979?
Your answer should be compact. 1.82. What is the ratio of the Earning from trade(% of GDP) of Cote d'Ivoire in 1975 to that in 1976?
Your answer should be compact. 0.94. What is the ratio of the Earning from trade(% of GDP) of Dominican Republic in 1975 to that in 1976?
Give a very brief answer. 1.23. What is the ratio of the Earning from trade(% of GDP) of Turkey in 1975 to that in 1976?
Make the answer very short. 1. What is the ratio of the Earning from trade(% of GDP) of Cote d'Ivoire in 1975 to that in 1977?
Your answer should be compact. 0.95. What is the ratio of the Earning from trade(% of GDP) in Dominican Republic in 1975 to that in 1977?
Ensure brevity in your answer.  1.29. What is the ratio of the Earning from trade(% of GDP) in Turkey in 1975 to that in 1977?
Provide a short and direct response. 1.07. What is the ratio of the Earning from trade(% of GDP) of Cote d'Ivoire in 1975 to that in 1978?
Give a very brief answer. 1.01. What is the ratio of the Earning from trade(% of GDP) of Dominican Republic in 1975 to that in 1978?
Provide a succinct answer. 1.42. What is the ratio of the Earning from trade(% of GDP) in Turkey in 1975 to that in 1978?
Provide a succinct answer. 1.3. What is the ratio of the Earning from trade(% of GDP) of Cote d'Ivoire in 1975 to that in 1979?
Keep it short and to the point. 1.08. What is the ratio of the Earning from trade(% of GDP) of Dominican Republic in 1975 to that in 1979?
Your response must be concise. 1.31. What is the ratio of the Earning from trade(% of GDP) in Turkey in 1975 to that in 1979?
Your answer should be compact. 1.68. What is the ratio of the Earning from trade(% of GDP) in Cote d'Ivoire in 1976 to that in 1977?
Provide a succinct answer. 1.01. What is the ratio of the Earning from trade(% of GDP) in Dominican Republic in 1976 to that in 1977?
Your answer should be compact. 1.05. What is the ratio of the Earning from trade(% of GDP) in Turkey in 1976 to that in 1977?
Provide a short and direct response. 1.07. What is the ratio of the Earning from trade(% of GDP) in Cote d'Ivoire in 1976 to that in 1978?
Offer a very short reply. 1.07. What is the ratio of the Earning from trade(% of GDP) of Dominican Republic in 1976 to that in 1978?
Your response must be concise. 1.16. What is the ratio of the Earning from trade(% of GDP) in Turkey in 1976 to that in 1978?
Make the answer very short. 1.31. What is the ratio of the Earning from trade(% of GDP) in Cote d'Ivoire in 1976 to that in 1979?
Ensure brevity in your answer.  1.15. What is the ratio of the Earning from trade(% of GDP) in Dominican Republic in 1976 to that in 1979?
Give a very brief answer. 1.07. What is the ratio of the Earning from trade(% of GDP) in Turkey in 1976 to that in 1979?
Your response must be concise. 1.69. What is the ratio of the Earning from trade(% of GDP) of Cote d'Ivoire in 1977 to that in 1978?
Keep it short and to the point. 1.06. What is the ratio of the Earning from trade(% of GDP) of Dominican Republic in 1977 to that in 1978?
Provide a succinct answer. 1.1. What is the ratio of the Earning from trade(% of GDP) of Turkey in 1977 to that in 1978?
Ensure brevity in your answer.  1.22. What is the ratio of the Earning from trade(% of GDP) in Cote d'Ivoire in 1977 to that in 1979?
Provide a succinct answer. 1.14. What is the ratio of the Earning from trade(% of GDP) of Turkey in 1977 to that in 1979?
Keep it short and to the point. 1.57. What is the ratio of the Earning from trade(% of GDP) of Cote d'Ivoire in 1978 to that in 1979?
Your answer should be compact. 1.07. What is the ratio of the Earning from trade(% of GDP) of Dominican Republic in 1978 to that in 1979?
Ensure brevity in your answer.  0.92. What is the ratio of the Earning from trade(% of GDP) of Turkey in 1978 to that in 1979?
Offer a very short reply. 1.29. What is the difference between the highest and the second highest Earning from trade(% of GDP) in Cote d'Ivoire?
Your answer should be very brief. 8.25. What is the difference between the highest and the second highest Earning from trade(% of GDP) in Dominican Republic?
Provide a succinct answer. 0.15. What is the difference between the highest and the second highest Earning from trade(% of GDP) in Turkey?
Offer a terse response. 1.09. What is the difference between the highest and the lowest Earning from trade(% of GDP) of Cote d'Ivoire?
Provide a succinct answer. 16.57. What is the difference between the highest and the lowest Earning from trade(% of GDP) in Dominican Republic?
Offer a terse response. 14.7. What is the difference between the highest and the lowest Earning from trade(% of GDP) of Turkey?
Ensure brevity in your answer.  6.71. 